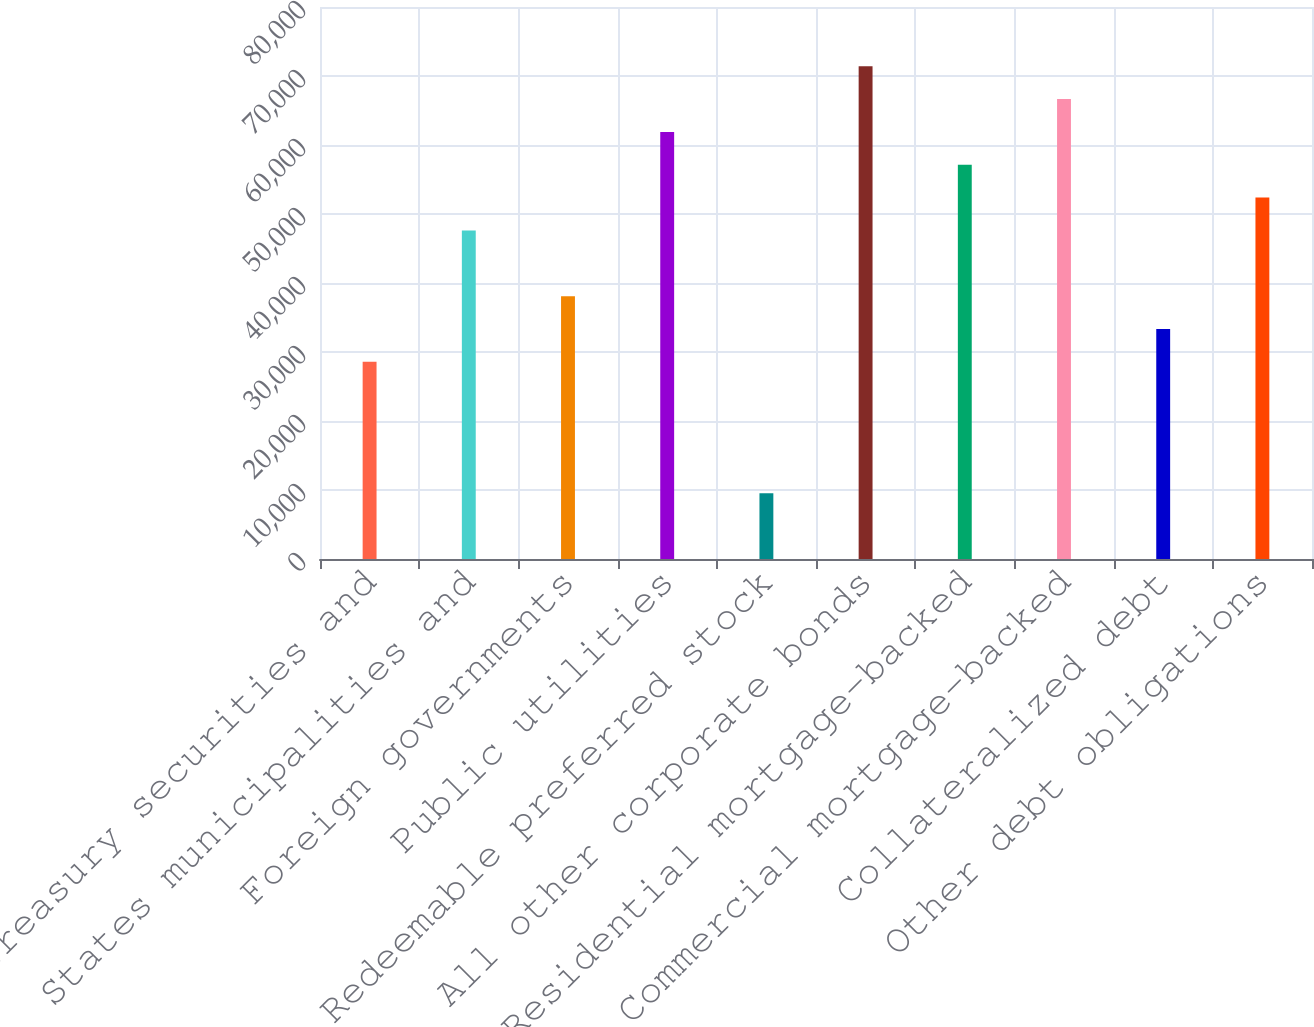Convert chart. <chart><loc_0><loc_0><loc_500><loc_500><bar_chart><fcel>US Treasury securities and<fcel>States municipalities and<fcel>Foreign governments<fcel>Public utilities<fcel>Redeemable preferred stock<fcel>All other corporate bonds<fcel>Residential mortgage-backed<fcel>Commercial mortgage-backed<fcel>Collateralized debt<fcel>Other debt obligations<nl><fcel>28573.5<fcel>47616.4<fcel>38094.9<fcel>61898.6<fcel>9530.56<fcel>71420.1<fcel>57137.9<fcel>66659.3<fcel>33334.2<fcel>52377.1<nl></chart> 